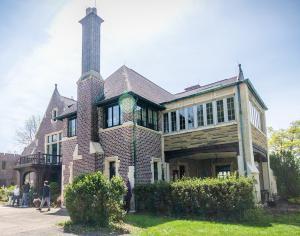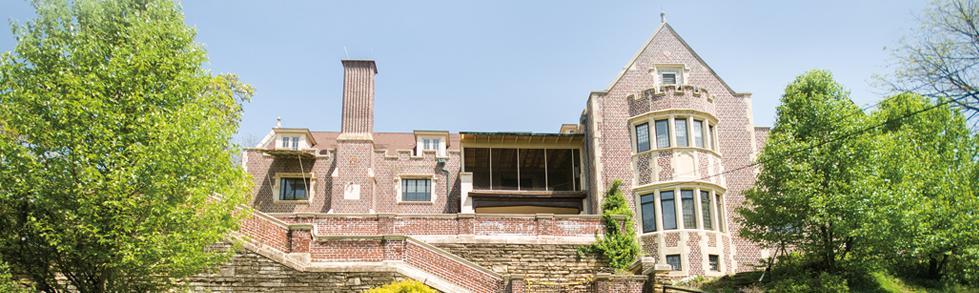The first image is the image on the left, the second image is the image on the right. For the images shown, is this caption "The building in the right image is yellow with a dark roof." true? Answer yes or no. No. 